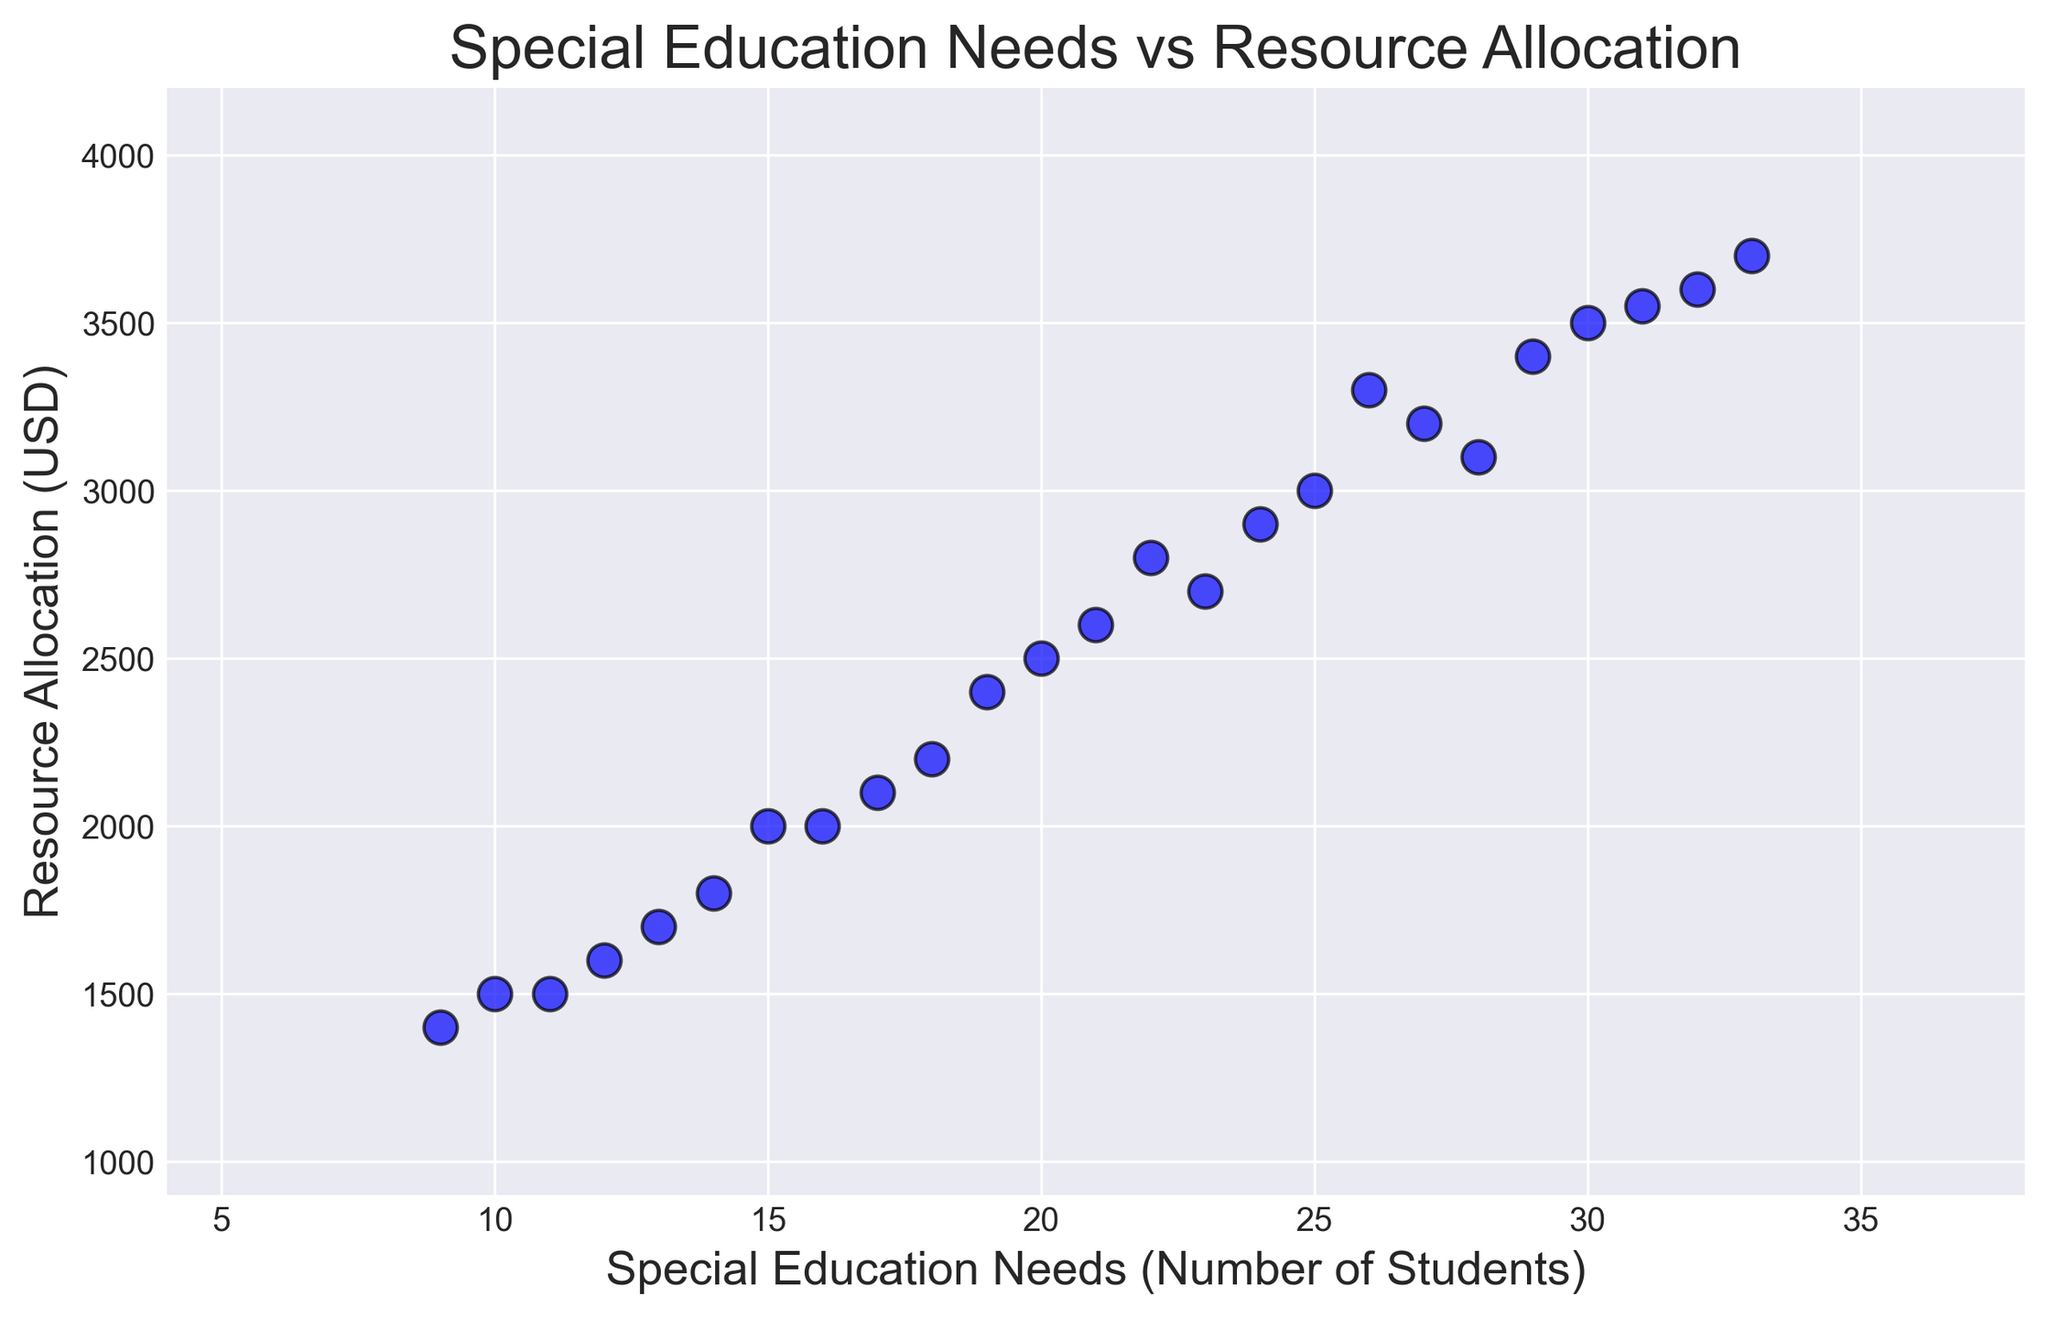which data point has the highest resource allocation? From the scatter plot, locate the data point that is highest on the y-axis. This point represents the highest resource allocation.
Answer: ID 25 (3700 USD) what is the range of special education needs identified? To find the range, identify the minimum and maximum values on the x-axis of the scatter plot. Calculate the difference between these two values.
Answer: Range: 33 - 9 = 24 how many data points have resource allocation higher than 3000 USD? Count the number of points that are positioned above the 3000 USD mark on the y-axis of the scatter plot.
Answer: 8 data points which data point has the lowest special education needs identified, and what is its corresponding resource allocation? Find the data point furthest to the left on the x-axis (indicating the lowest special education needs), then read the corresponding y-value for resource allocation.
Answer: ID 23 (1400 USD) is there a visible relationship between special education needs and resource allocation? Observe the general trend of the points on the scatter plot. Check if there is an upward (positive) or downward (negative) trend, or if the points are scattered without any clear pattern.
Answer: Yes, positive relationship what is the median value of the resource allocation? List all resource allocation values in ascending order and find the middle value. If the number of points is even, average the two middle values.
Answer: Median: 2600 USD how does the resource allocation change as special education needs increase from 10 to 20? Identify points on the plot where special education needs values range from 10 to 20, then check the corresponding resource allocation values to observe any change.
Answer: Generally increases are there any data points with the same resource allocation but different special education needs? Look for data points aligned horizontally, indicating the same y-value (resource allocation) but different x-values (special education needs).
Answer: Yes which data point is closest to the average resource allocation, and what are its special education needs? Calculate the average resource allocation by summing up all resource allocation values and dividing by the number of data points. Locate the data point closest to this average value on the y-axis, then check its x-value.
Answer: ID 2 (2500 USD) what is the difference in resource allocation between the highest and lowest special education needs identified? Identify the highest and lowest special education needs on the x-axis. Find the corresponding resource allocation values and calculate the difference between them.
Answer: 2300 USD (3700 - 1400) 